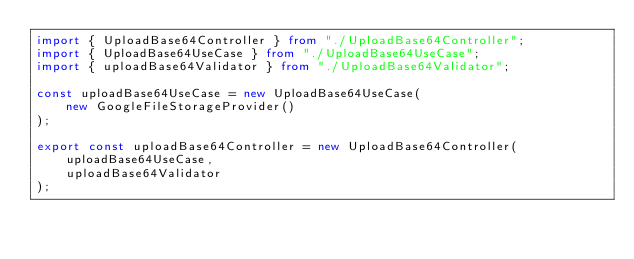<code> <loc_0><loc_0><loc_500><loc_500><_TypeScript_>import { UploadBase64Controller } from "./UploadBase64Controller";
import { UploadBase64UseCase } from "./UploadBase64UseCase";
import { uploadBase64Validator } from "./UploadBase64Validator";

const uploadBase64UseCase = new UploadBase64UseCase(
	new GoogleFileStorageProvider()
);

export const uploadBase64Controller = new UploadBase64Controller(
	uploadBase64UseCase,
	uploadBase64Validator
);
</code> 